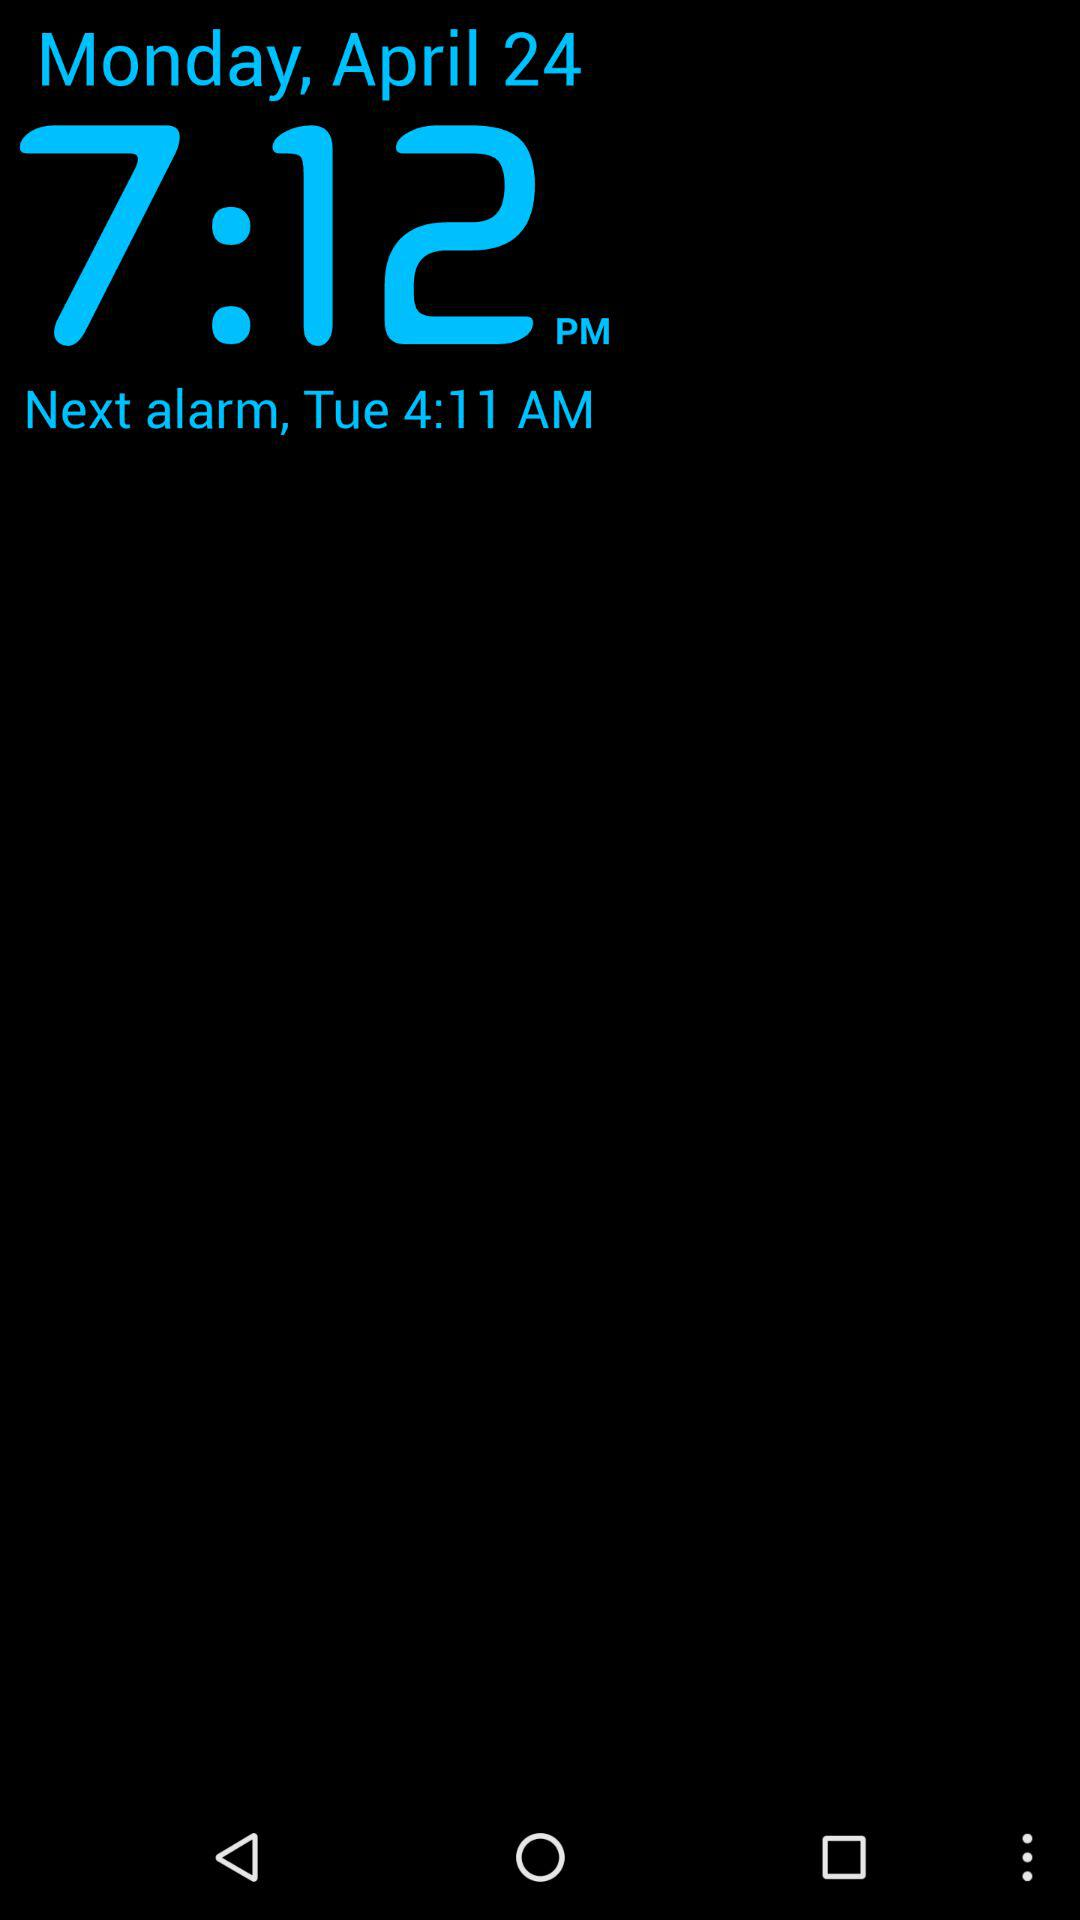What time is the next alarm? The next alarm is at 4:11 AM. 